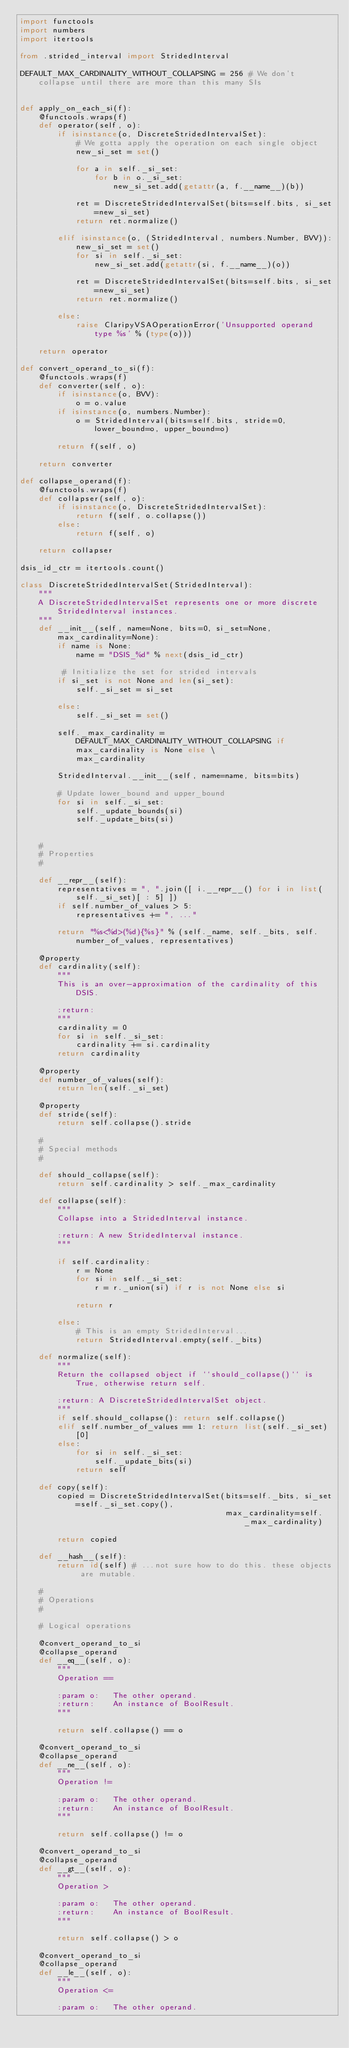Convert code to text. <code><loc_0><loc_0><loc_500><loc_500><_Python_>import functools
import numbers
import itertools

from .strided_interval import StridedInterval

DEFAULT_MAX_CARDINALITY_WITHOUT_COLLAPSING = 256 # We don't collapse until there are more than this many SIs


def apply_on_each_si(f):
    @functools.wraps(f)
    def operator(self, o):
        if isinstance(o, DiscreteStridedIntervalSet):
            # We gotta apply the operation on each single object
            new_si_set = set()

            for a in self._si_set:
                for b in o._si_set:
                    new_si_set.add(getattr(a, f.__name__)(b))

            ret = DiscreteStridedIntervalSet(bits=self.bits, si_set=new_si_set)
            return ret.normalize()

        elif isinstance(o, (StridedInterval, numbers.Number, BVV)):
            new_si_set = set()
            for si in self._si_set:
                new_si_set.add(getattr(si, f.__name__)(o))

            ret = DiscreteStridedIntervalSet(bits=self.bits, si_set=new_si_set)
            return ret.normalize()

        else:
            raise ClaripyVSAOperationError('Unsupported operand type %s' % (type(o)))

    return operator

def convert_operand_to_si(f):
    @functools.wraps(f)
    def converter(self, o):
        if isinstance(o, BVV):
            o = o.value
        if isinstance(o, numbers.Number):
            o = StridedInterval(bits=self.bits, stride=0, lower_bound=o, upper_bound=o)

        return f(self, o)

    return converter

def collapse_operand(f):
    @functools.wraps(f)
    def collapser(self, o):
        if isinstance(o, DiscreteStridedIntervalSet):
            return f(self, o.collapse())
        else:
            return f(self, o)

    return collapser

dsis_id_ctr = itertools.count()

class DiscreteStridedIntervalSet(StridedInterval):
    """
    A DiscreteStridedIntervalSet represents one or more discrete StridedInterval instances.
    """
    def __init__(self, name=None, bits=0, si_set=None, max_cardinality=None):
        if name is None:
            name = "DSIS_%d" % next(dsis_id_ctr)

         # Initialize the set for strided intervals
        if si_set is not None and len(si_set):
            self._si_set = si_set

        else:
            self._si_set = set()

        self._max_cardinality = DEFAULT_MAX_CARDINALITY_WITHOUT_COLLAPSING if max_cardinality is None else \
            max_cardinality

        StridedInterval.__init__(self, name=name, bits=bits)

        # Update lower_bound and upper_bound
        for si in self._si_set:
            self._update_bounds(si)
            self._update_bits(si)


    #
    # Properties
    #

    def __repr__(self):
        representatives = ", ".join([ i.__repr__() for i in list(self._si_set)[ : 5] ])
        if self.number_of_values > 5:
            representatives += ", ..."

        return "%s<%d>(%d){%s}" % (self._name, self._bits, self.number_of_values, representatives)

    @property
    def cardinality(self):
        """
        This is an over-approximation of the cardinality of this DSIS.

        :return:
        """
        cardinality = 0
        for si in self._si_set:
            cardinality += si.cardinality
        return cardinality

    @property
    def number_of_values(self):
        return len(self._si_set)

    @property
    def stride(self):
        return self.collapse().stride

    #
    # Special methods
    #

    def should_collapse(self):
        return self.cardinality > self._max_cardinality

    def collapse(self):
        """
        Collapse into a StridedInterval instance.

        :return: A new StridedInterval instance.
        """

        if self.cardinality:
            r = None
            for si in self._si_set:
                r = r._union(si) if r is not None else si

            return r

        else:
            # This is an empty StridedInterval...
            return StridedInterval.empty(self._bits)

    def normalize(self):
        """
        Return the collapsed object if ``should_collapse()`` is True, otherwise return self.

        :return: A DiscreteStridedIntervalSet object.
        """
        if self.should_collapse(): return self.collapse()
        elif self.number_of_values == 1: return list(self._si_set)[0]
        else:
            for si in self._si_set:
                self._update_bits(si)
            return self

    def copy(self):
        copied = DiscreteStridedIntervalSet(bits=self._bits, si_set=self._si_set.copy(),
                                            max_cardinality=self._max_cardinality)

        return copied

    def __hash__(self):
        return id(self) # ...not sure how to do this. these objects are mutable.

    #
    # Operations
    #

    # Logical operations

    @convert_operand_to_si
    @collapse_operand
    def __eq__(self, o):
        """
        Operation ==

        :param o:   The other operand.
        :return:    An instance of BoolResult.
        """

        return self.collapse() == o

    @convert_operand_to_si
    @collapse_operand
    def __ne__(self, o):
        """
        Operation !=

        :param o:   The other operand.
        :return:    An instance of BoolResult.
        """

        return self.collapse() != o

    @convert_operand_to_si
    @collapse_operand
    def __gt__(self, o):
        """
        Operation >

        :param o:   The other operand.
        :return:    An instance of BoolResult.
        """

        return self.collapse() > o

    @convert_operand_to_si
    @collapse_operand
    def __le__(self, o):
        """
        Operation <=

        :param o:   The other operand.</code> 